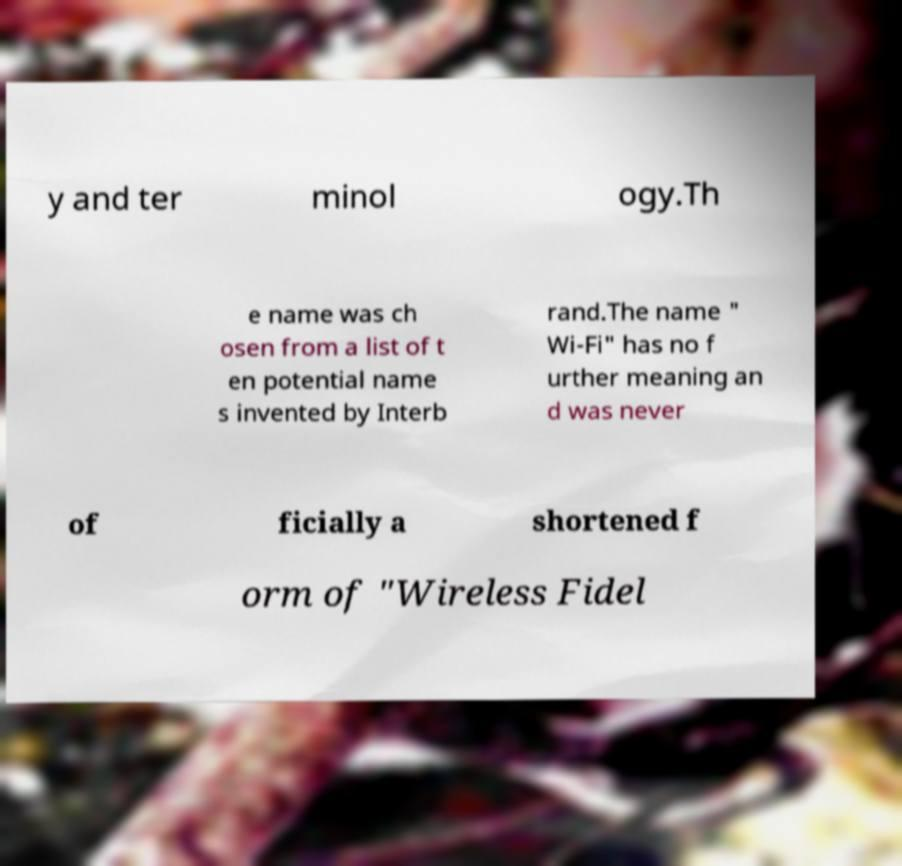What messages or text are displayed in this image? I need them in a readable, typed format. y and ter minol ogy.Th e name was ch osen from a list of t en potential name s invented by Interb rand.The name " Wi-Fi" has no f urther meaning an d was never of ficially a shortened f orm of "Wireless Fidel 